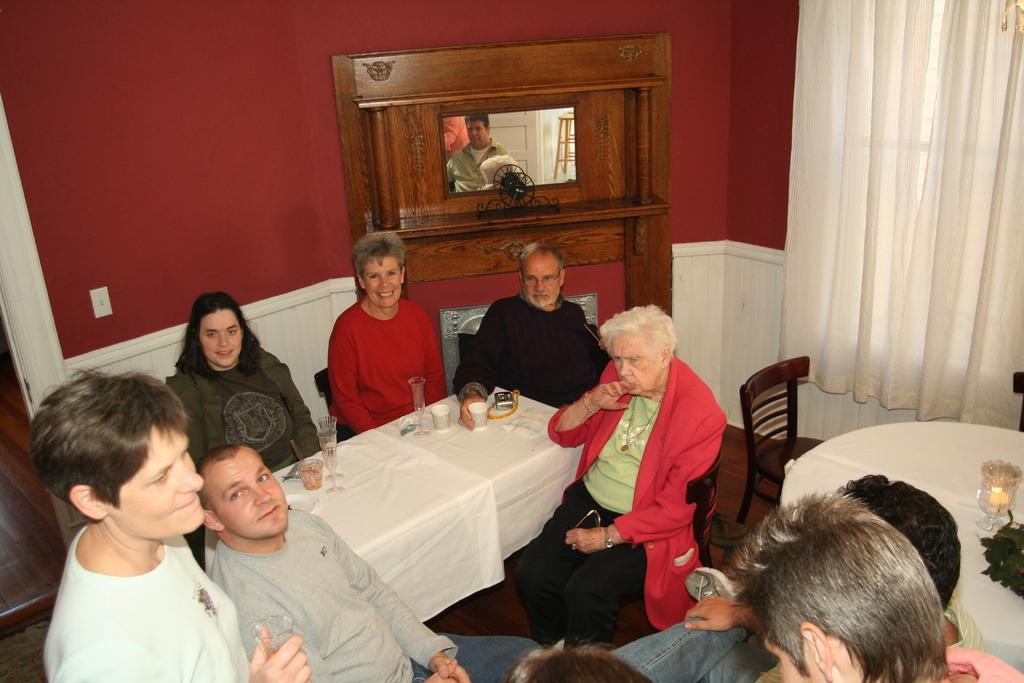In one or two sentences, can you explain what this image depicts? This picture is taken inside a room. There are few people in the room siting on chairs at the tables. A table cloth, and glasses are placed on the table. On the right corner of the image there is table and a candle is placed on it. In the background there is a mirror and in it a person can be seen and there is a door and ladder just behind him. In the background there is a wall and curtain.  